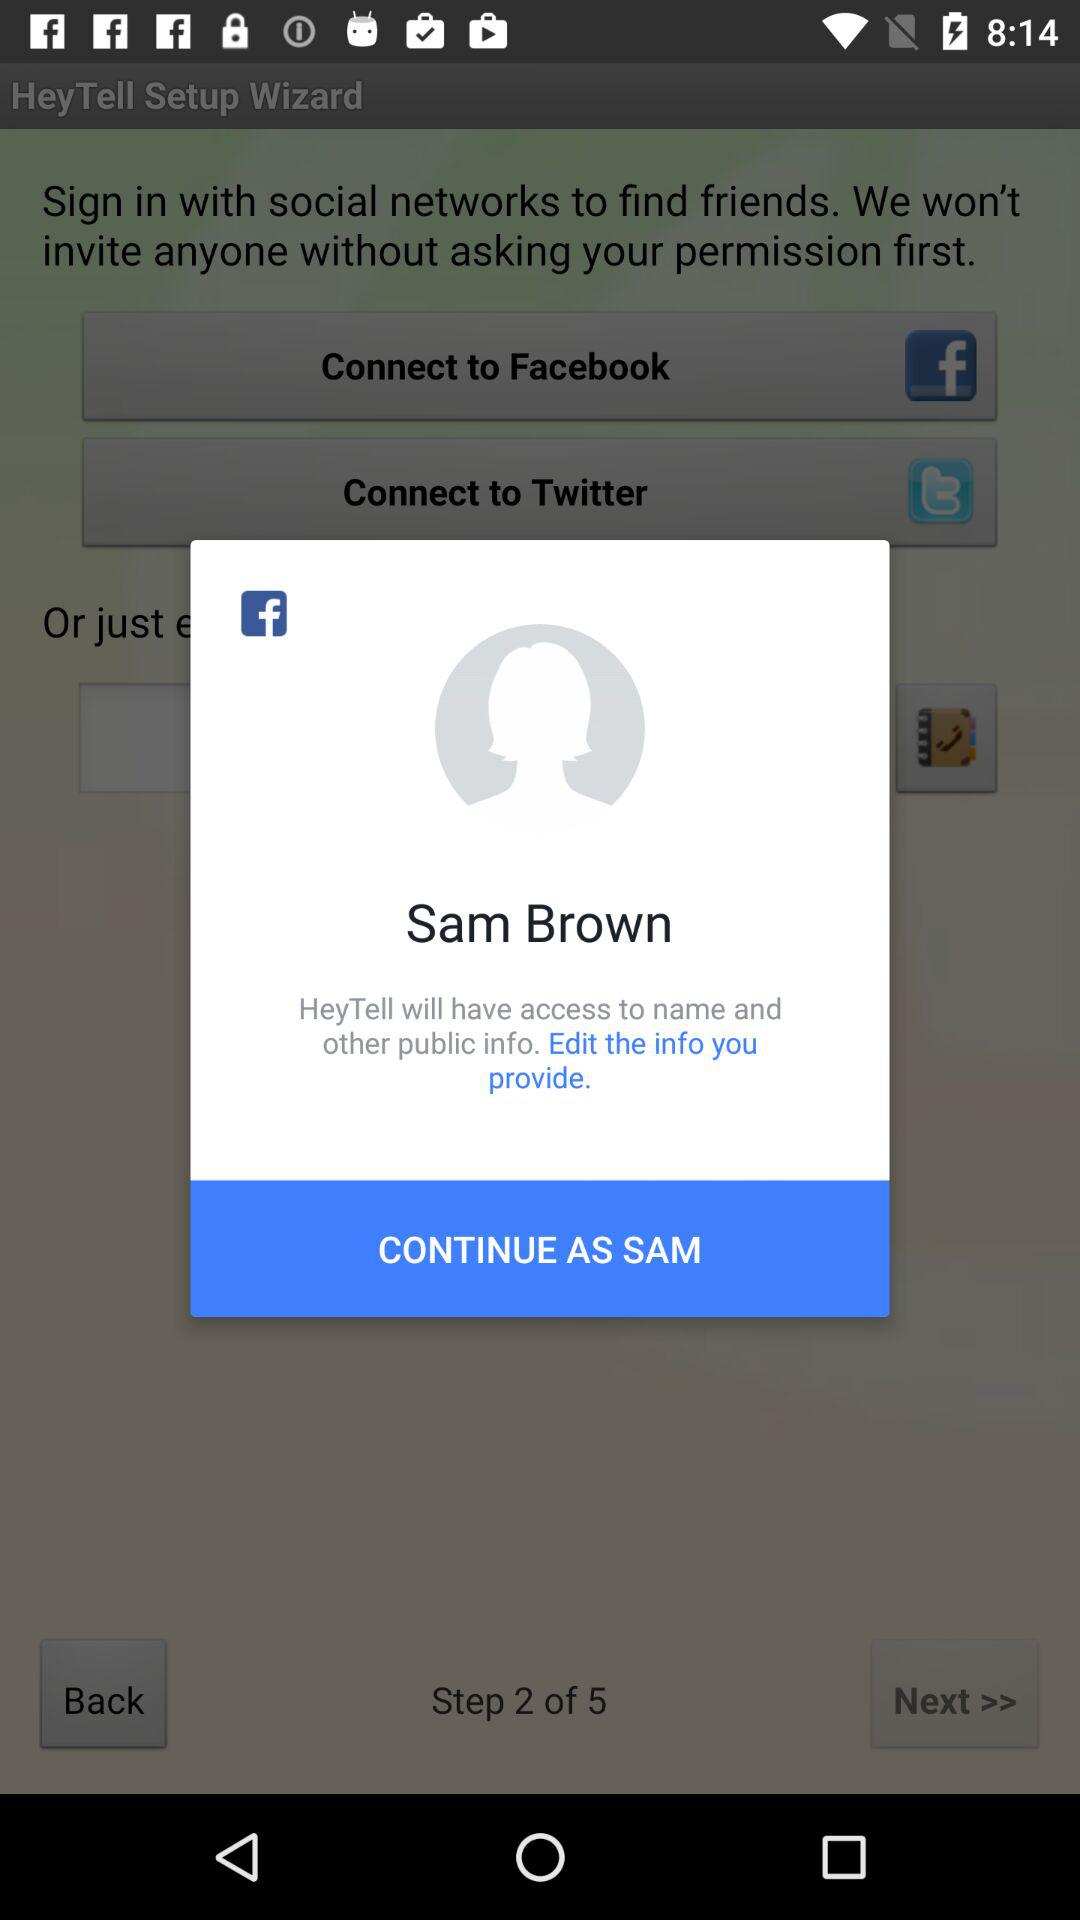What is the name of the user? The name of the user is Sam Brown. 